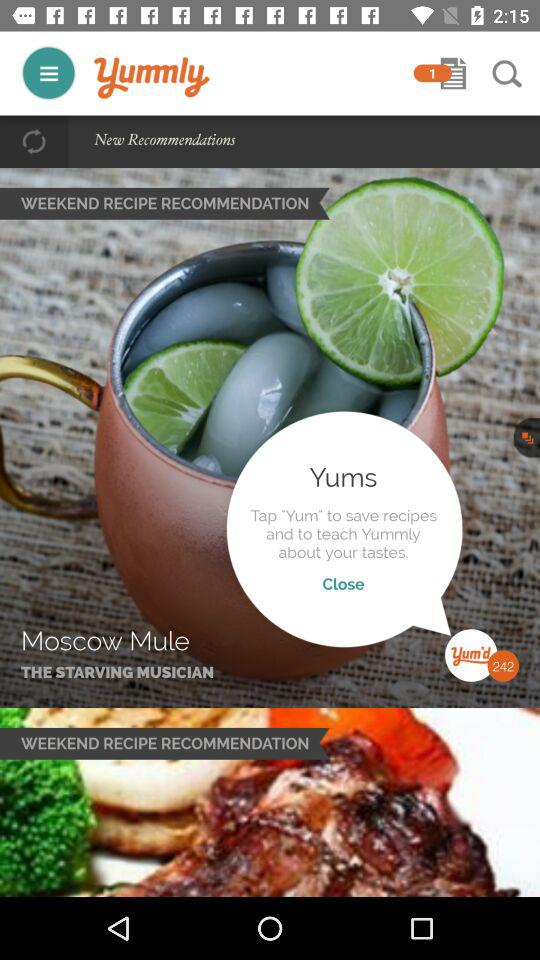What is the name of the recipe? The name of the recipe is "Moscow Mule". 